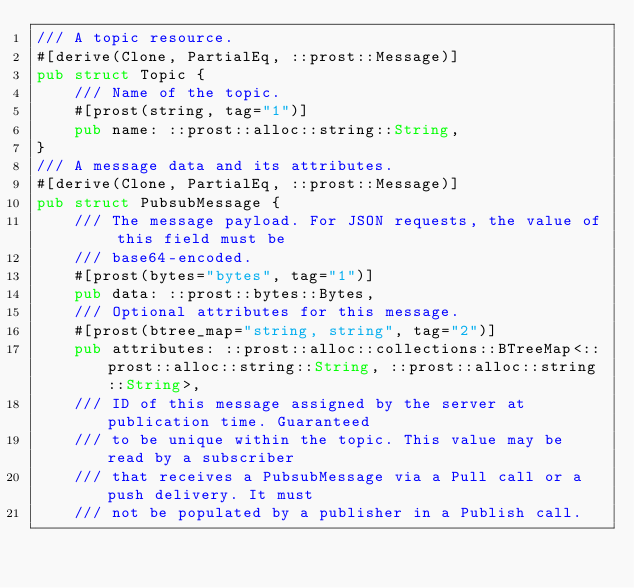<code> <loc_0><loc_0><loc_500><loc_500><_Rust_>/// A topic resource.
#[derive(Clone, PartialEq, ::prost::Message)]
pub struct Topic {
    /// Name of the topic.
    #[prost(string, tag="1")]
    pub name: ::prost::alloc::string::String,
}
/// A message data and its attributes.
#[derive(Clone, PartialEq, ::prost::Message)]
pub struct PubsubMessage {
    /// The message payload. For JSON requests, the value of this field must be
    /// base64-encoded.
    #[prost(bytes="bytes", tag="1")]
    pub data: ::prost::bytes::Bytes,
    /// Optional attributes for this message.
    #[prost(btree_map="string, string", tag="2")]
    pub attributes: ::prost::alloc::collections::BTreeMap<::prost::alloc::string::String, ::prost::alloc::string::String>,
    /// ID of this message assigned by the server at publication time. Guaranteed
    /// to be unique within the topic. This value may be read by a subscriber
    /// that receives a PubsubMessage via a Pull call or a push delivery. It must
    /// not be populated by a publisher in a Publish call.</code> 